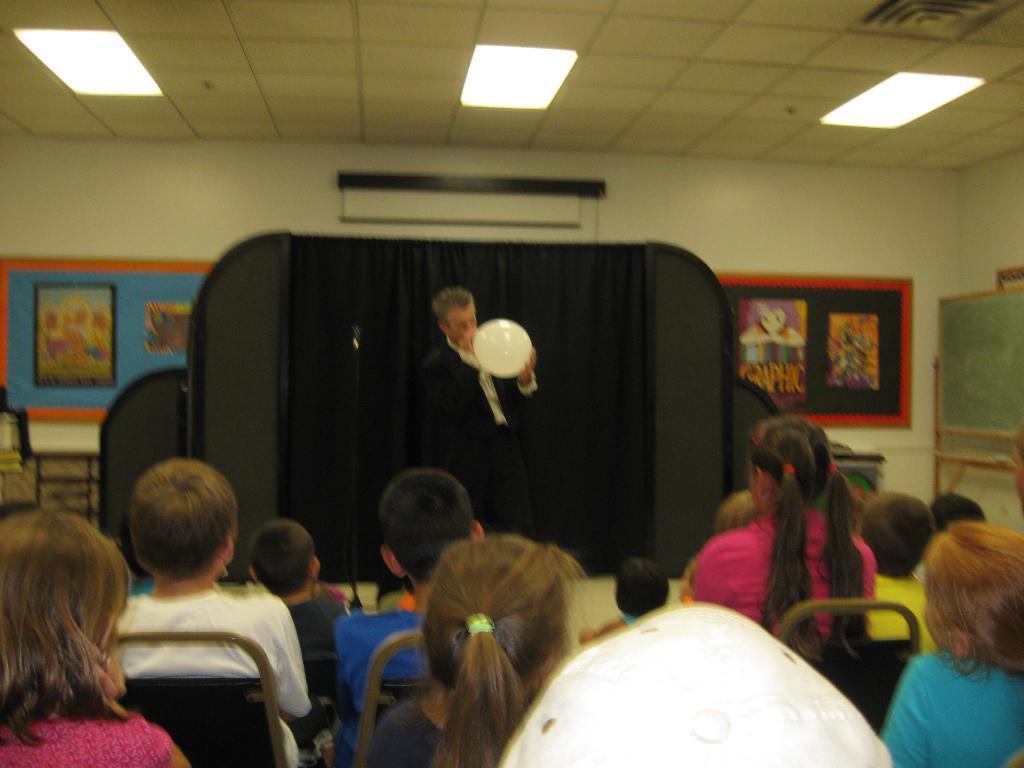Can you describe this image briefly? There are people sitting in the foreground area of the image, there is a person holding a balloon, posters, other objects and lamps in the background. 